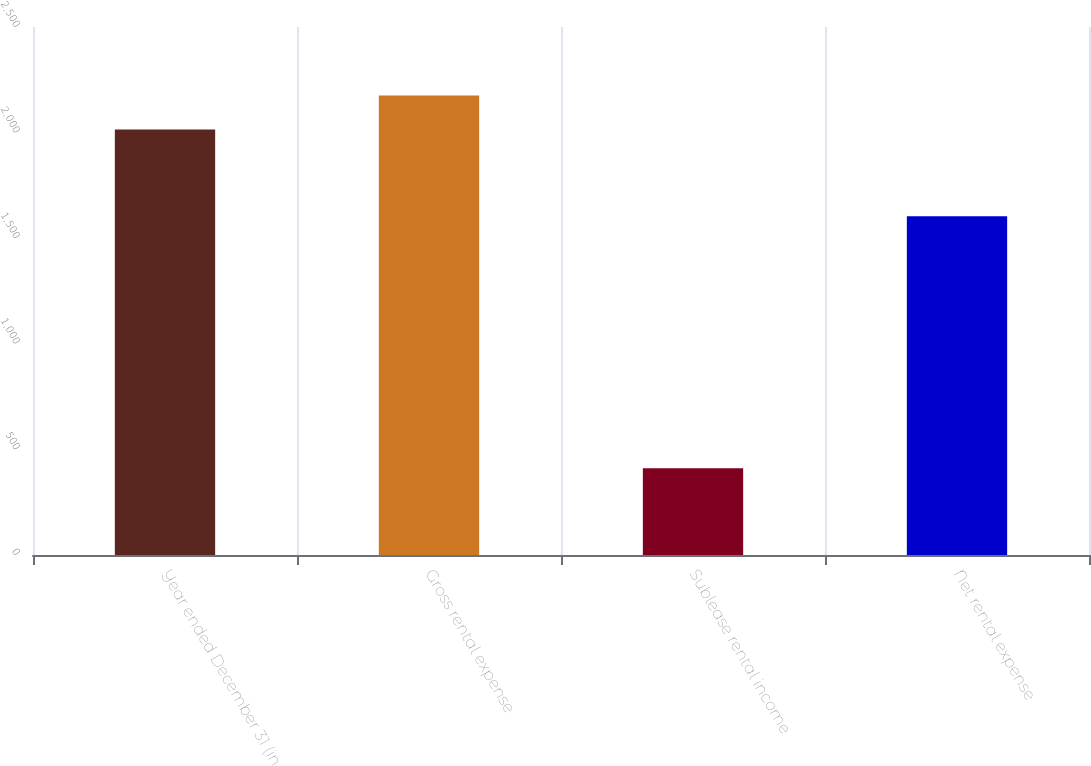<chart> <loc_0><loc_0><loc_500><loc_500><bar_chart><fcel>Year ended December 31 (in<fcel>Gross rental expense<fcel>Sublease rental income<fcel>Net rental expense<nl><fcel>2015<fcel>2175.4<fcel>411<fcel>1604<nl></chart> 